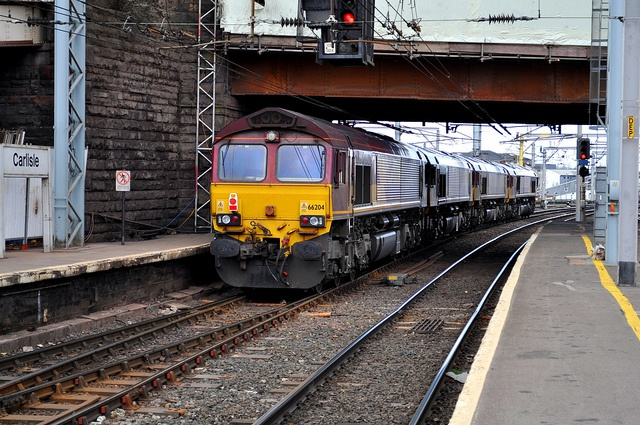Describe the objects in this image and their specific colors. I can see train in black, orange, gray, and darkgray tones, traffic light in black and gray tones, and traffic light in black, gray, and navy tones in this image. 